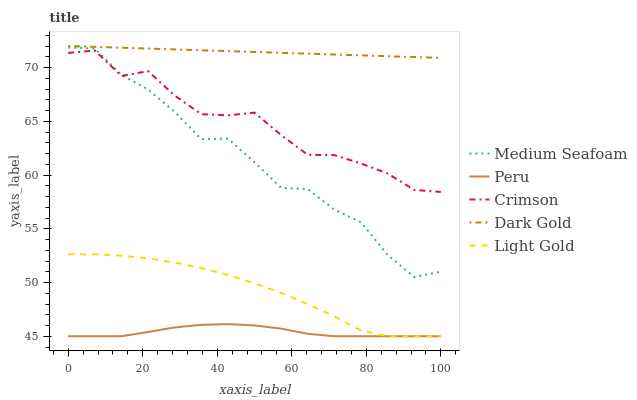Does Peru have the minimum area under the curve?
Answer yes or no. Yes. Does Dark Gold have the maximum area under the curve?
Answer yes or no. Yes. Does Light Gold have the minimum area under the curve?
Answer yes or no. No. Does Light Gold have the maximum area under the curve?
Answer yes or no. No. Is Dark Gold the smoothest?
Answer yes or no. Yes. Is Medium Seafoam the roughest?
Answer yes or no. Yes. Is Light Gold the smoothest?
Answer yes or no. No. Is Light Gold the roughest?
Answer yes or no. No. Does Light Gold have the lowest value?
Answer yes or no. Yes. Does Medium Seafoam have the lowest value?
Answer yes or no. No. Does Dark Gold have the highest value?
Answer yes or no. Yes. Does Light Gold have the highest value?
Answer yes or no. No. Is Medium Seafoam less than Dark Gold?
Answer yes or no. Yes. Is Crimson greater than Peru?
Answer yes or no. Yes. Does Medium Seafoam intersect Crimson?
Answer yes or no. Yes. Is Medium Seafoam less than Crimson?
Answer yes or no. No. Is Medium Seafoam greater than Crimson?
Answer yes or no. No. Does Medium Seafoam intersect Dark Gold?
Answer yes or no. No. 